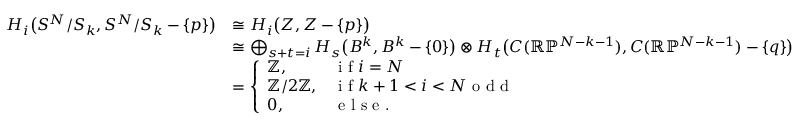<formula> <loc_0><loc_0><loc_500><loc_500>\begin{array} { r l } { H _ { i } \left ( S ^ { N } / S _ { k } , S ^ { N } / S _ { k } - \{ p \} \right ) } & { \cong H _ { i } \left ( Z , Z - \{ p \} \right ) } \\ & { \cong \bigoplus _ { s + t = i } H _ { s } \left ( B ^ { k } , B ^ { k } - \{ 0 \} \right ) \otimes H _ { t } \left ( C ( \mathbb { R } \mathbb { P } ^ { N - k - 1 } ) , C ( \mathbb { R } \mathbb { P } ^ { N - k - 1 } ) - \{ q \} \right ) } \\ & { = \left \{ \begin{array} { l l } { \mathbb { Z } , } & { i f i = N } \\ { \mathbb { Z } / 2 \mathbb { Z } , } & { i f k + 1 < i < N o d d } \\ { 0 , } & { e l s e . } \end{array} } \end{array}</formula> 